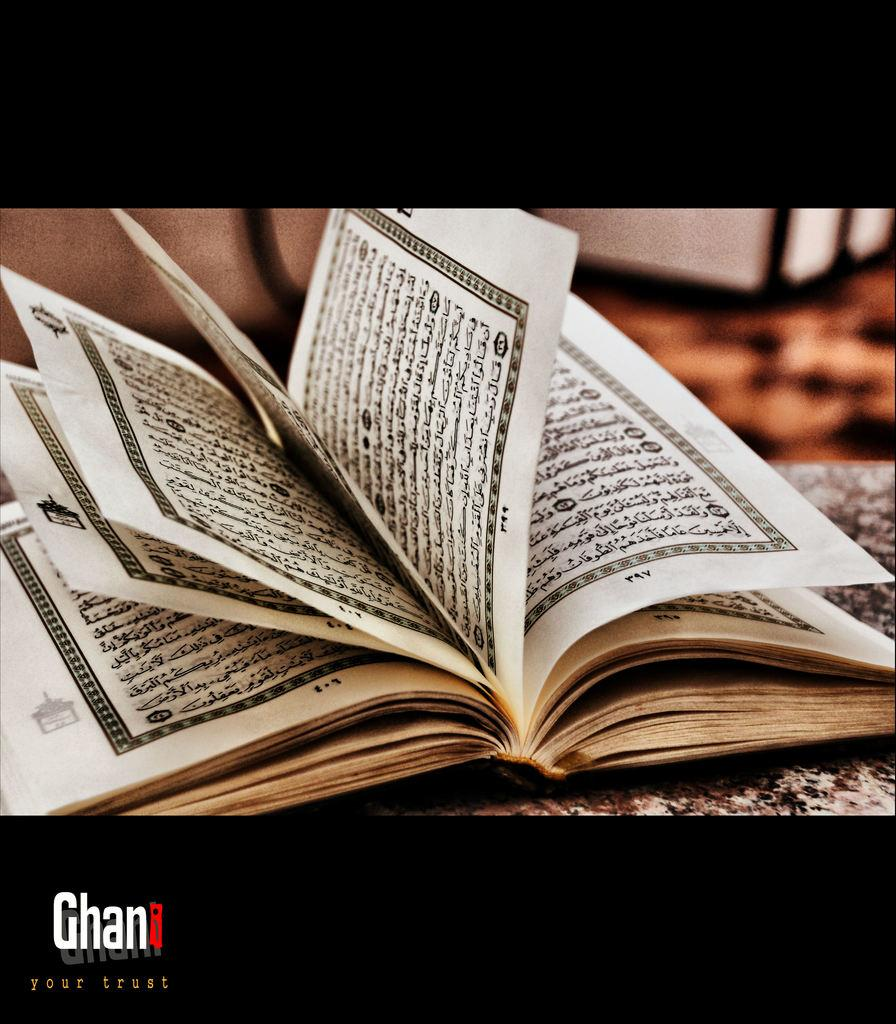<image>
Share a concise interpretation of the image provided. Below the picture of a book are the words "your trust". 